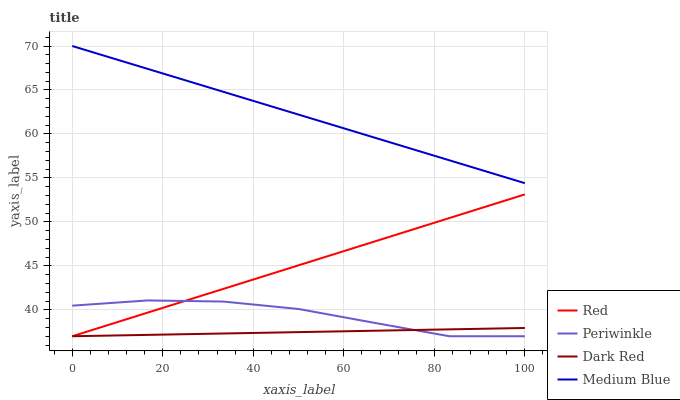Does Periwinkle have the minimum area under the curve?
Answer yes or no. No. Does Periwinkle have the maximum area under the curve?
Answer yes or no. No. Is Medium Blue the smoothest?
Answer yes or no. No. Is Medium Blue the roughest?
Answer yes or no. No. Does Medium Blue have the lowest value?
Answer yes or no. No. Does Periwinkle have the highest value?
Answer yes or no. No. Is Periwinkle less than Medium Blue?
Answer yes or no. Yes. Is Medium Blue greater than Dark Red?
Answer yes or no. Yes. Does Periwinkle intersect Medium Blue?
Answer yes or no. No. 